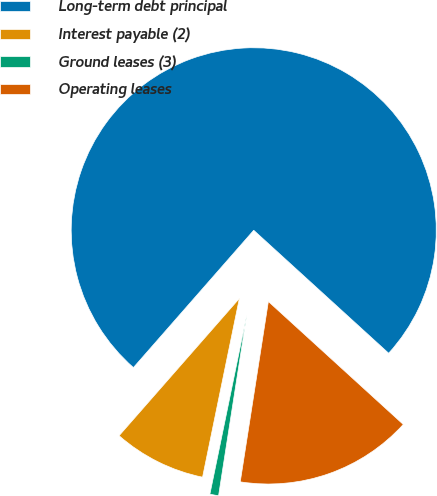Convert chart. <chart><loc_0><loc_0><loc_500><loc_500><pie_chart><fcel>Long-term debt principal<fcel>Interest payable (2)<fcel>Ground leases (3)<fcel>Operating leases<nl><fcel>75.31%<fcel>8.22%<fcel>0.77%<fcel>15.7%<nl></chart> 